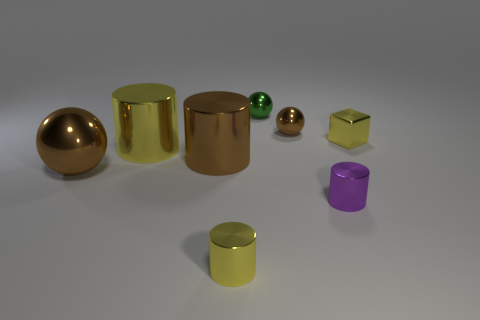Add 1 yellow cylinders. How many objects exist? 9 Subtract all blocks. How many objects are left? 7 Add 2 purple cylinders. How many purple cylinders are left? 3 Add 4 tiny brown metal balls. How many tiny brown metal balls exist? 5 Subtract 0 red blocks. How many objects are left? 8 Subtract all brown shiny cylinders. Subtract all big things. How many objects are left? 4 